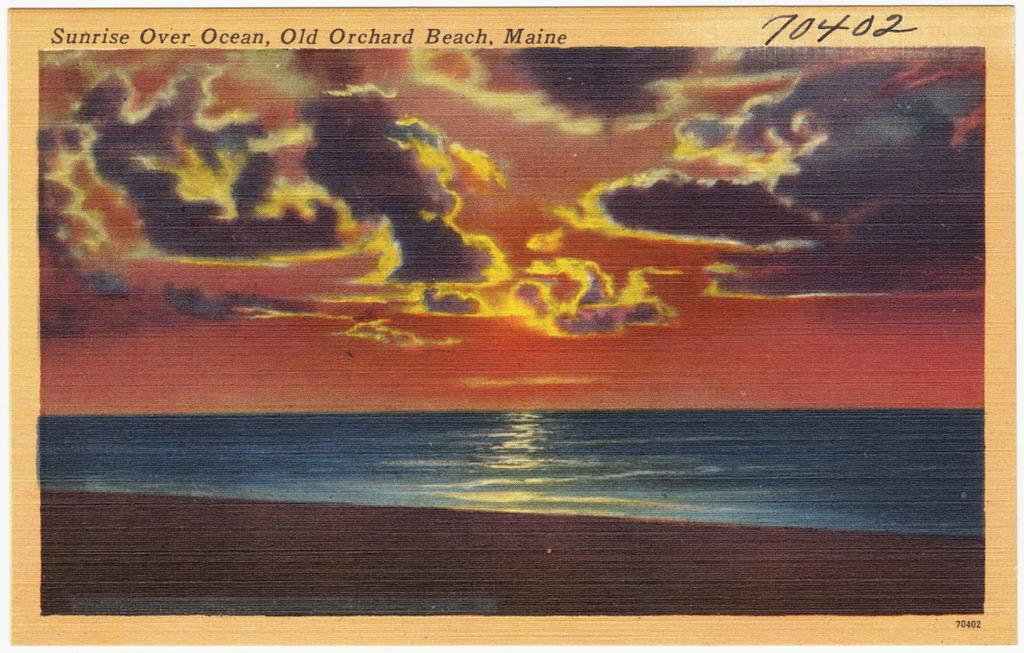Provide a one-sentence caption for the provided image. A painting of a sunrise as seen from Old Orchard Beach. 